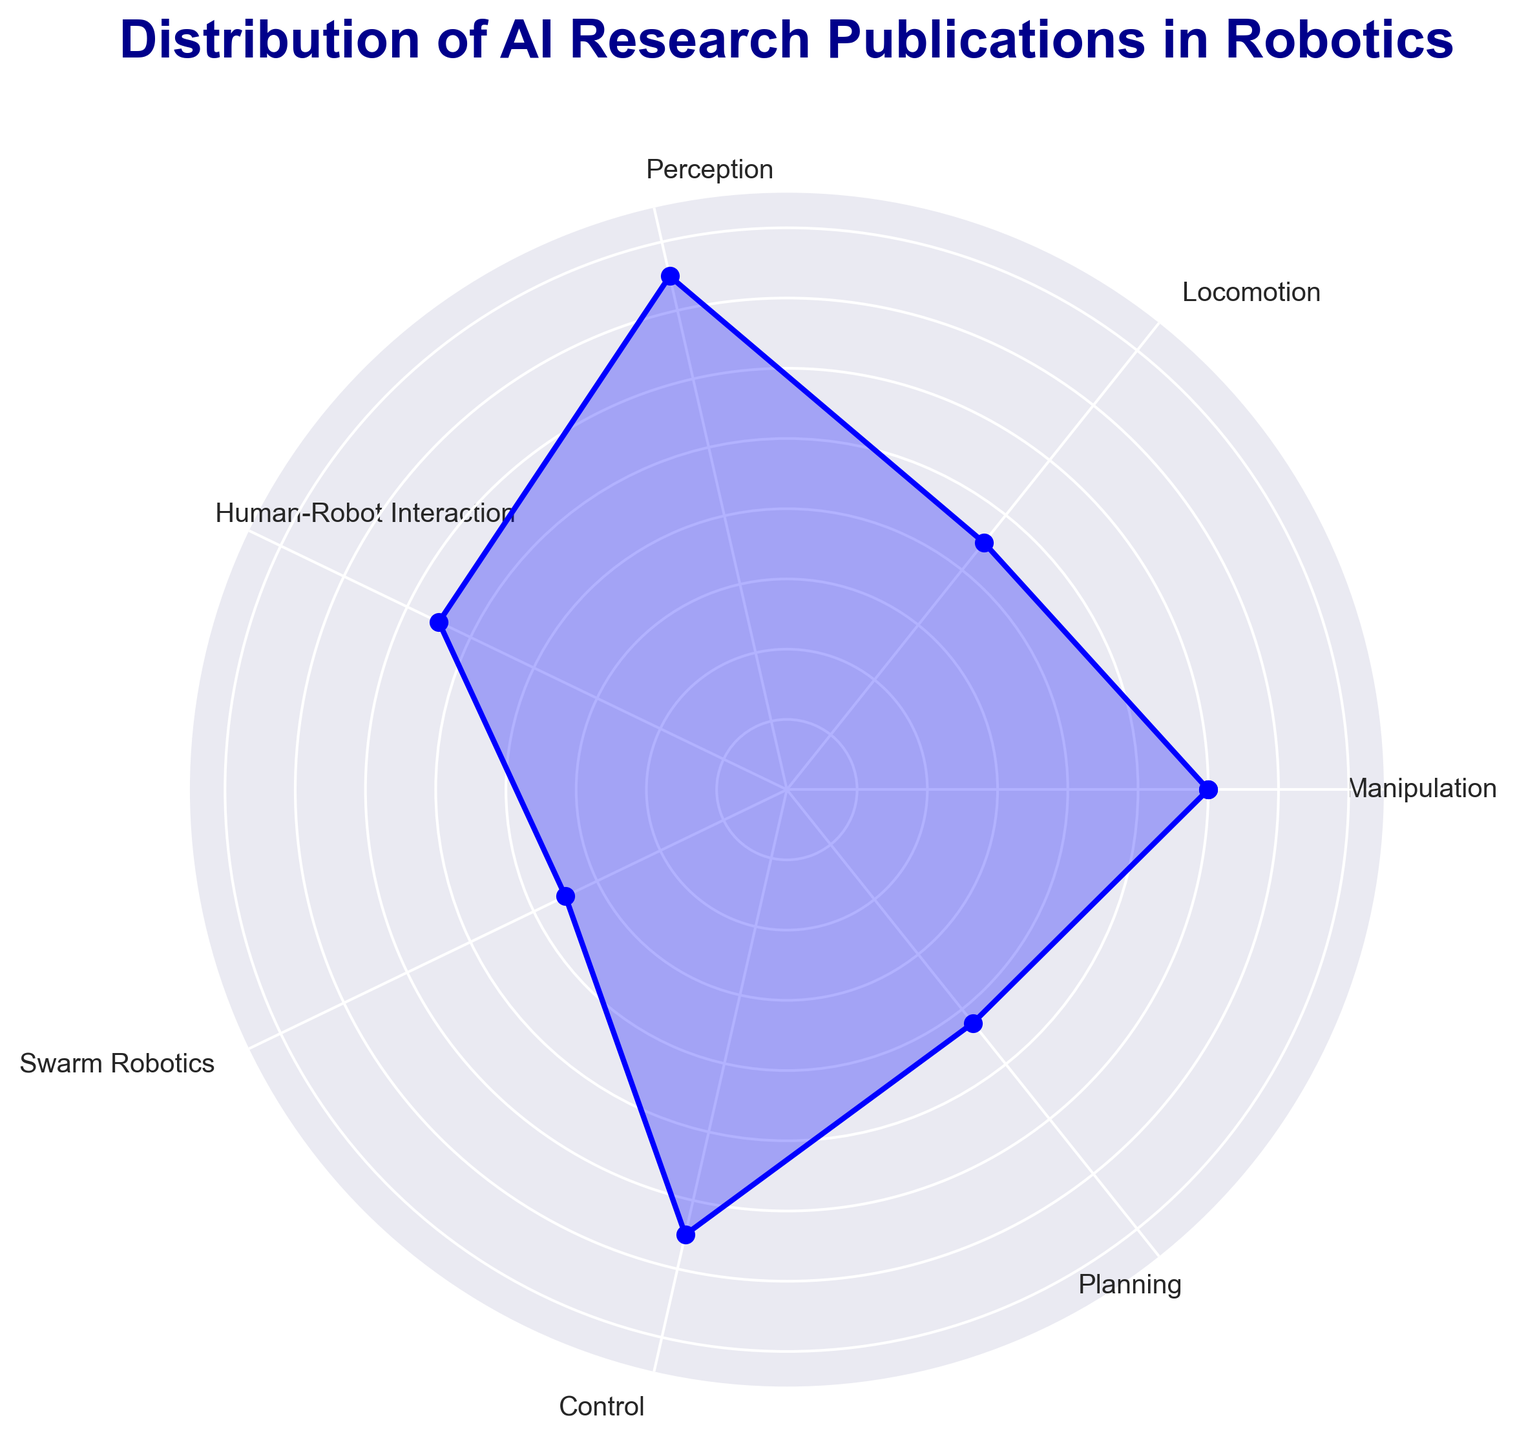Which subfield has the highest number of publications? To find this, look at the peak point of the radar chart. The highest value can be observed at the subfield 'Perception'.
Answer: Perception Which subfield has the lowest number of publications? To determine this, look for the lowest point on the radar chart. The subfield with the fewest publications is 'Swarm Robotics'.
Answer: Swarm Robotics How many more publications does 'Perception' have than 'Locomotion'? First, identify the number of publications in 'Perception' (150) and 'Locomotion' (90). Subtract the number of publications in 'Locomotion' from 'Perception': 150 - 90 = 60.
Answer: 60 Which subfield has a publication number closest to the average number of all subfields? First, find the average number of publications: (120 + 90 + 150 + 110 + 70 + 130 + 85) / 7 ≈ 107.14. Then, identify the subfield with the number nearest to this average, which is 'Human-Robot Interaction' with 110 publications.
Answer: Human-Robot Interaction Compare 'Manipulation' and 'Planning'. Which subfield has more publications, and by how much? 'Manipulation' has 120 publications, while 'Planning' has 85. Subtract 'Planning' from 'Manipulation': 120 - 85 = 35. Thus, 'Manipulation' has more publications by 35.
Answer: Manipulation, 35 Which subfields have a publication number greater than 100? Look at the points on the radar chart that are above the 100-mark threshold. These subfields are 'Manipulation', 'Perception', 'Human-Robot Interaction', and 'Control'.
Answer: Manipulation, Perception, Human-Robot Interaction, Control What is the range of the publication numbers across all subfields? Find the maximum number (150 for 'Perception') and the minimum number (70 for 'Swarm Robotics'). The range is calculated as 150 - 70 = 80.
Answer: 80 Is the number of publications in 'Control' greater than that in 'Locomotion' and 'Planning' combined? First, calculate the total publications in 'Locomotion' and 'Planning': 90 + 85 = 175. Then compare it to 'Control' with 130 publications. 130 is less than 175.
Answer: No What proportion of the total publications is from 'Swarm Robotics'? First, calculate the total number of publications: 120 + 90 + 150 + 110 + 70 + 130 + 85 = 755. Then, find the proportion for 'Swarm Robotics': 70 / 755 ≈ 0.0927, which is about 9.27%.
Answer: Approximately 9.27% 